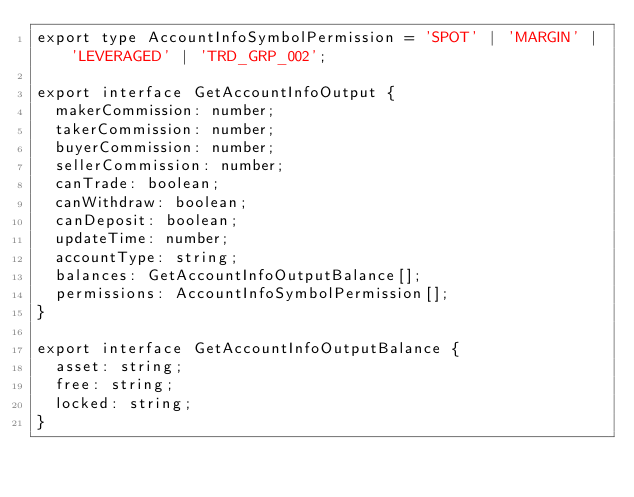<code> <loc_0><loc_0><loc_500><loc_500><_TypeScript_>export type AccountInfoSymbolPermission = 'SPOT' | 'MARGIN' | 'LEVERAGED' | 'TRD_GRP_002';

export interface GetAccountInfoOutput {
  makerCommission: number;
  takerCommission: number;
  buyerCommission: number;
  sellerCommission: number;
  canTrade: boolean;
  canWithdraw: boolean;
  canDeposit: boolean;
  updateTime: number;
  accountType: string;
  balances: GetAccountInfoOutputBalance[];
  permissions: AccountInfoSymbolPermission[];
}

export interface GetAccountInfoOutputBalance {
  asset: string;
  free: string;
  locked: string;
}
</code> 